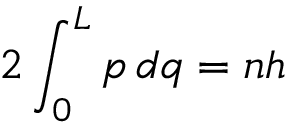Convert formula to latex. <formula><loc_0><loc_0><loc_500><loc_500>2 \int _ { 0 } ^ { L } p \, d q = n h</formula> 